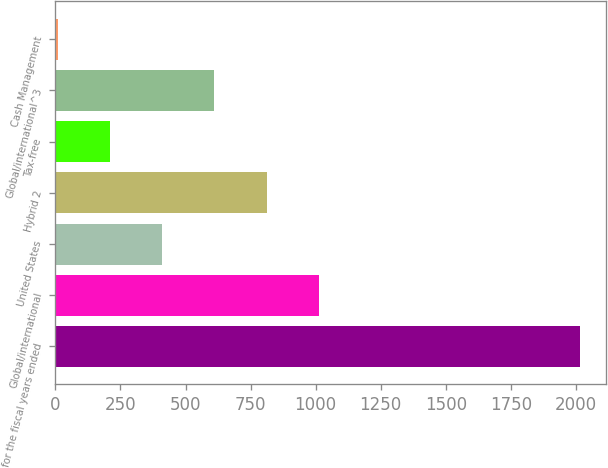Convert chart to OTSL. <chart><loc_0><loc_0><loc_500><loc_500><bar_chart><fcel>for the fiscal years ended<fcel>Global/international<fcel>United States<fcel>Hybrid 2<fcel>Tax-free<fcel>Global/international^3<fcel>Cash Management<nl><fcel>2015<fcel>1012<fcel>410.2<fcel>811.4<fcel>209.6<fcel>610.8<fcel>9<nl></chart> 